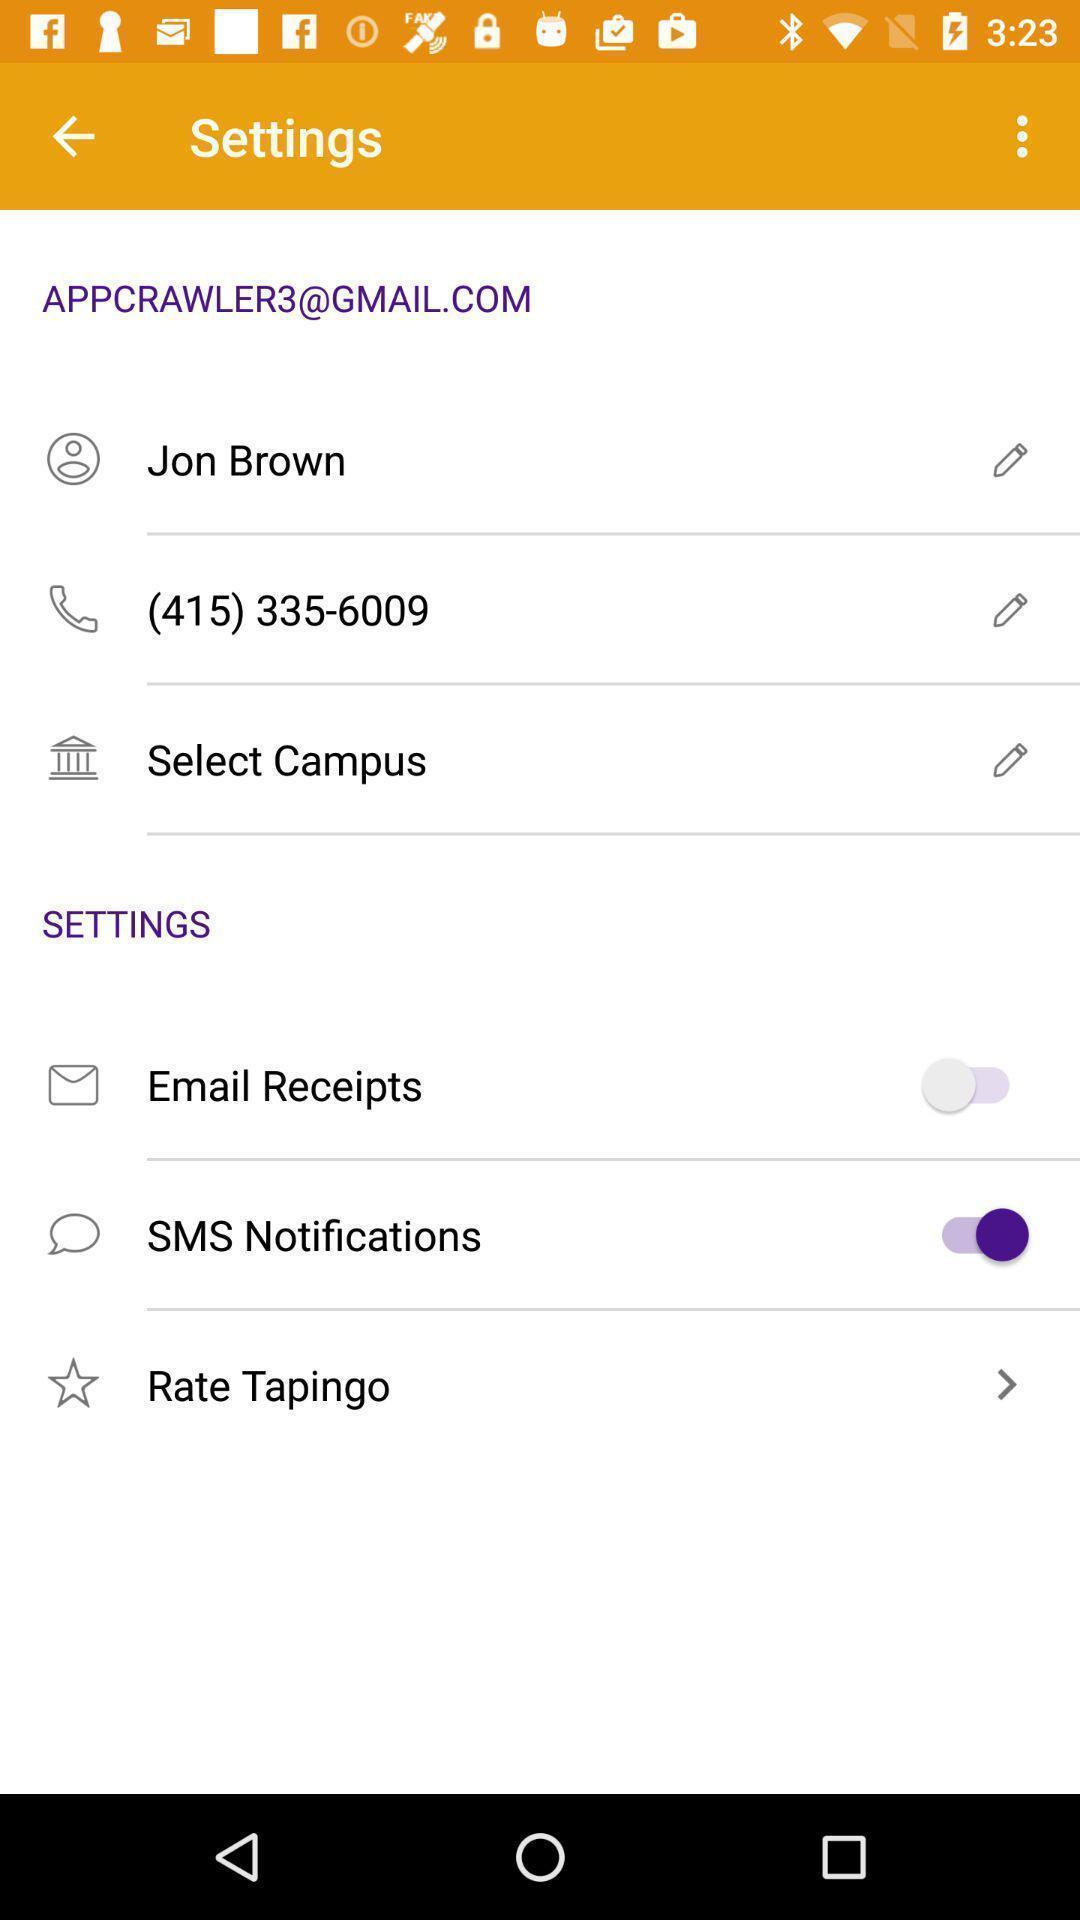Explain what's happening in this screen capture. Settings page. 